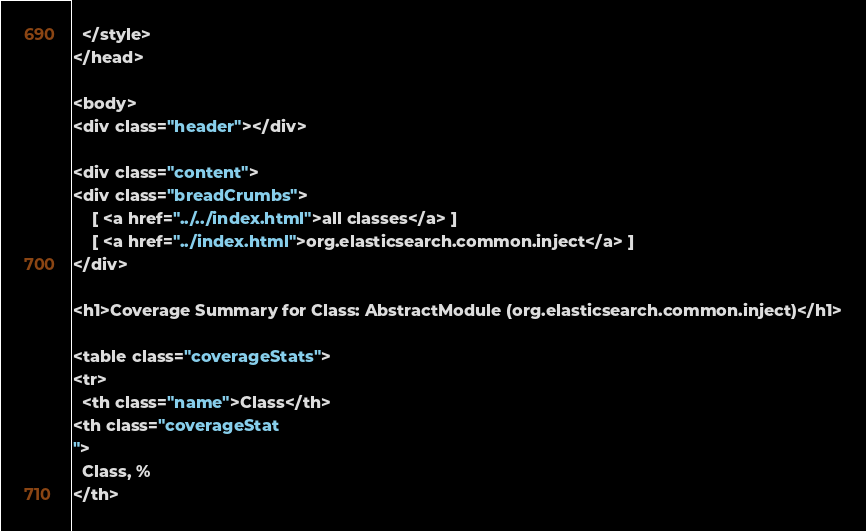Convert code to text. <code><loc_0><loc_0><loc_500><loc_500><_HTML_>  </style>
</head>

<body>
<div class="header"></div>

<div class="content">
<div class="breadCrumbs">
    [ <a href="../../index.html">all classes</a> ]
    [ <a href="../index.html">org.elasticsearch.common.inject</a> ]
</div>

<h1>Coverage Summary for Class: AbstractModule (org.elasticsearch.common.inject)</h1>

<table class="coverageStats">
<tr>
  <th class="name">Class</th>
<th class="coverageStat 
">
  Class, %
</th></code> 